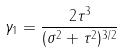Convert formula to latex. <formula><loc_0><loc_0><loc_500><loc_500>\gamma _ { 1 } = \frac { 2 \tau ^ { 3 } } { ( \sigma ^ { 2 } + \tau ^ { 2 } ) ^ { 3 / 2 } }</formula> 